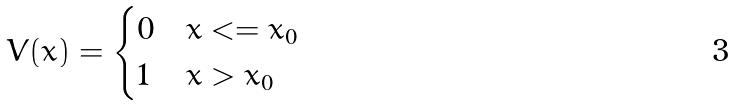<formula> <loc_0><loc_0><loc_500><loc_500>V ( x ) = \begin{cases} 0 & x < = x _ { 0 } \\ 1 & x > x _ { 0 } \\ \end{cases}</formula> 